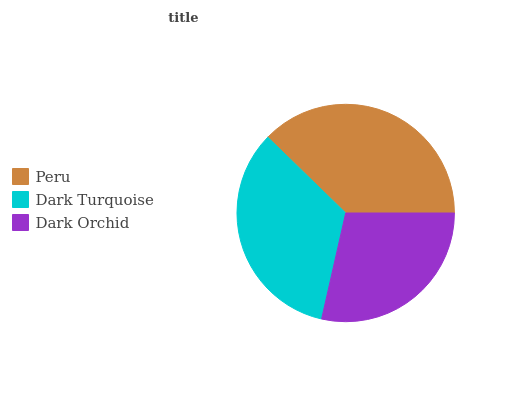Is Dark Orchid the minimum?
Answer yes or no. Yes. Is Peru the maximum?
Answer yes or no. Yes. Is Dark Turquoise the minimum?
Answer yes or no. No. Is Dark Turquoise the maximum?
Answer yes or no. No. Is Peru greater than Dark Turquoise?
Answer yes or no. Yes. Is Dark Turquoise less than Peru?
Answer yes or no. Yes. Is Dark Turquoise greater than Peru?
Answer yes or no. No. Is Peru less than Dark Turquoise?
Answer yes or no. No. Is Dark Turquoise the high median?
Answer yes or no. Yes. Is Dark Turquoise the low median?
Answer yes or no. Yes. Is Dark Orchid the high median?
Answer yes or no. No. Is Dark Orchid the low median?
Answer yes or no. No. 